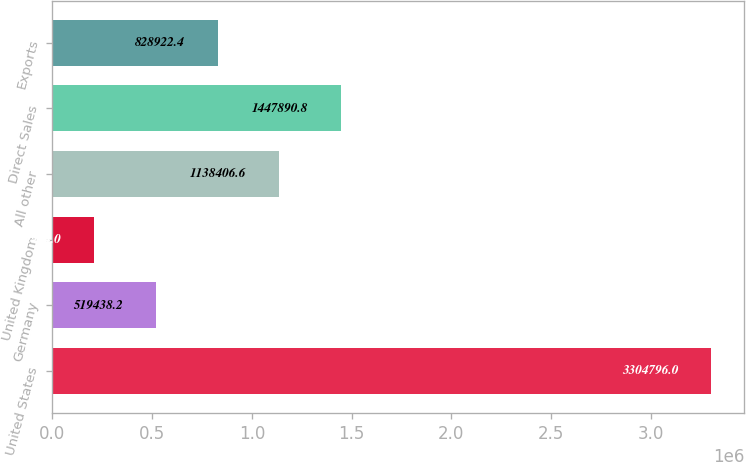Convert chart. <chart><loc_0><loc_0><loc_500><loc_500><bar_chart><fcel>United States<fcel>Germany<fcel>United Kingdom<fcel>All other<fcel>Direct Sales<fcel>Exports<nl><fcel>3.3048e+06<fcel>519438<fcel>209954<fcel>1.13841e+06<fcel>1.44789e+06<fcel>828922<nl></chart> 